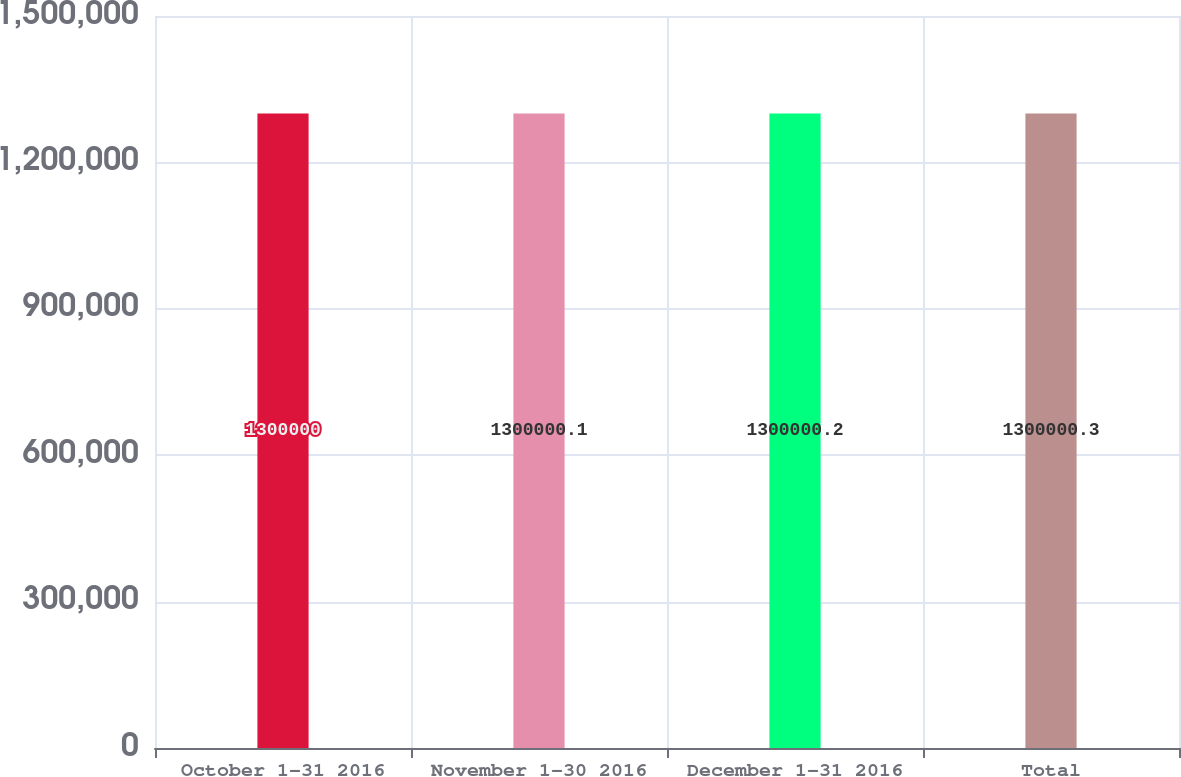Convert chart. <chart><loc_0><loc_0><loc_500><loc_500><bar_chart><fcel>October 1-31 2016<fcel>November 1-30 2016<fcel>December 1-31 2016<fcel>Total<nl><fcel>1.3e+06<fcel>1.3e+06<fcel>1.3e+06<fcel>1.3e+06<nl></chart> 